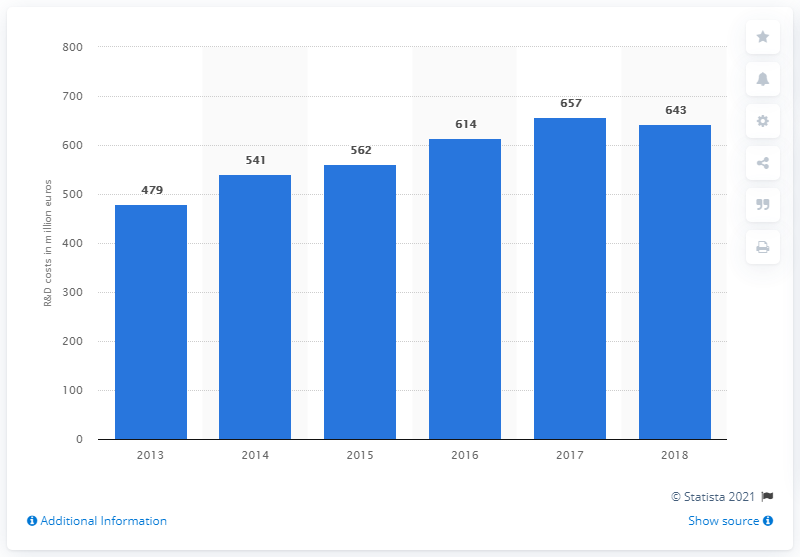Could you explain how R&D investments impact Ferrari's performance in the market? Research and development investments are crucial for automotive companies like Ferrari, as they lead to the creation of new technologies, improved performance, and enhanced safety features in their vehicles. These advancements can boost Ferrari's reputation for innovation, strengthen their brand identity, and ultimately drive sales by appealing to customers seeking the latest and most advanced sports cars on the market. 